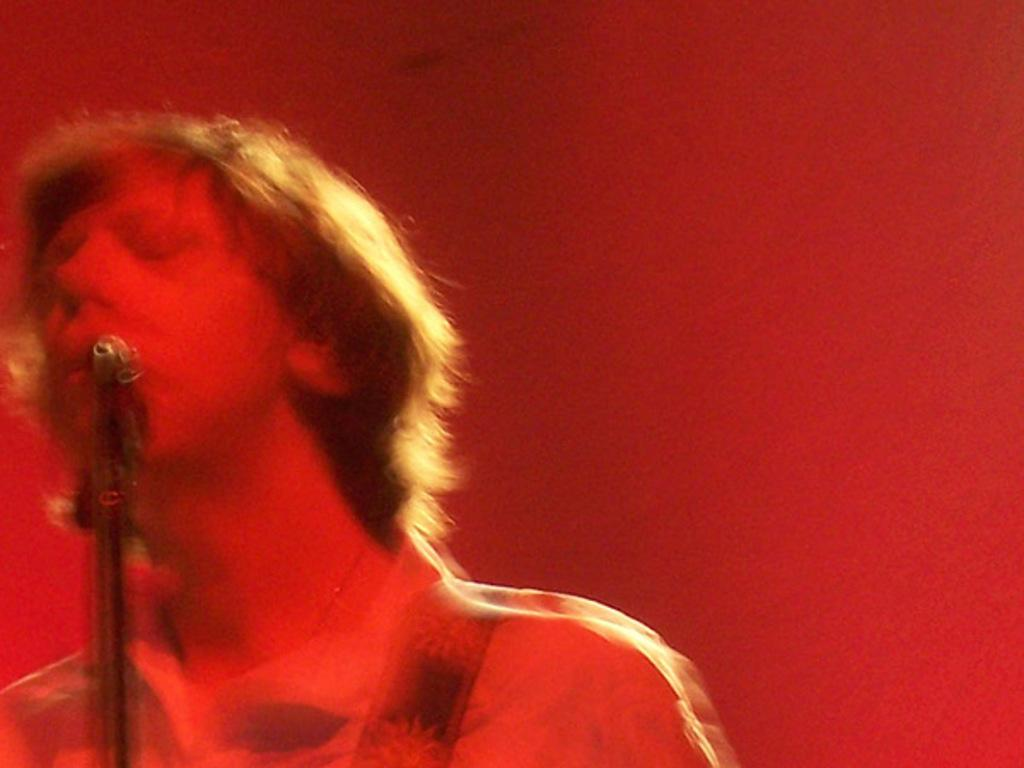What is the main subject of the image? There is a person in the image. What can be seen behind the person? The person is in front of a tripod. How would you describe the overall color tone of the image? The image has a reddish color tone. How many tomatoes are on the person's finger in the image? There are no tomatoes or fingers visible in the image, so it's not possible to answer that question. 